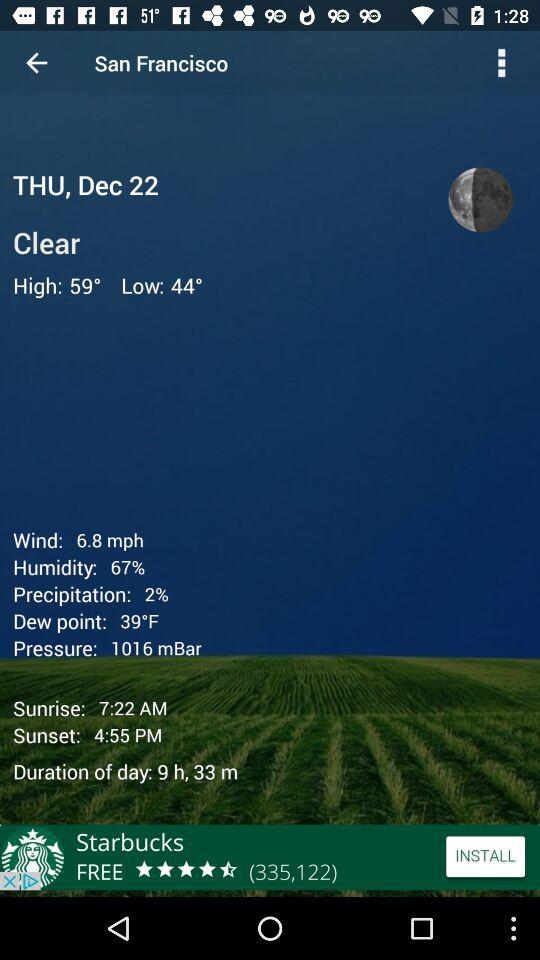What is the weather like in San Francisco? The weather is clear. 